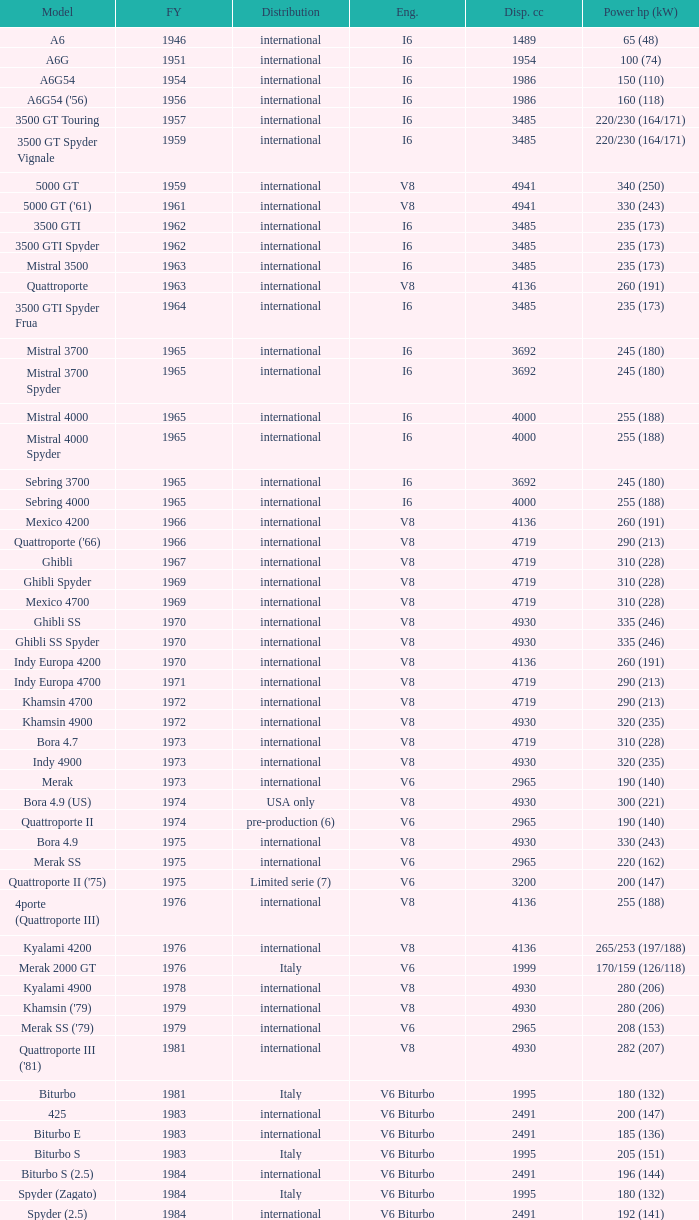What is Power HP (kW), when First Year is greater than 1965, when Distribution is "International", when Engine is V6 Biturbo, and when Model is "425"? 200 (147). 